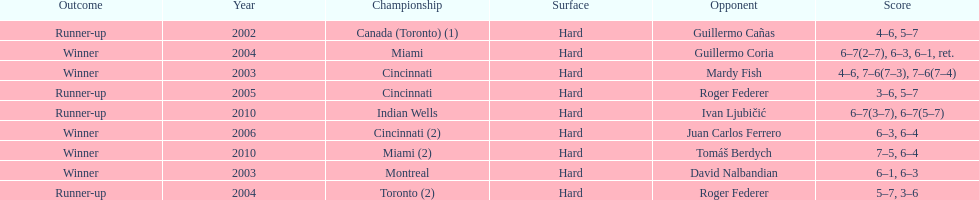How many times was the championship in miami? 2. 